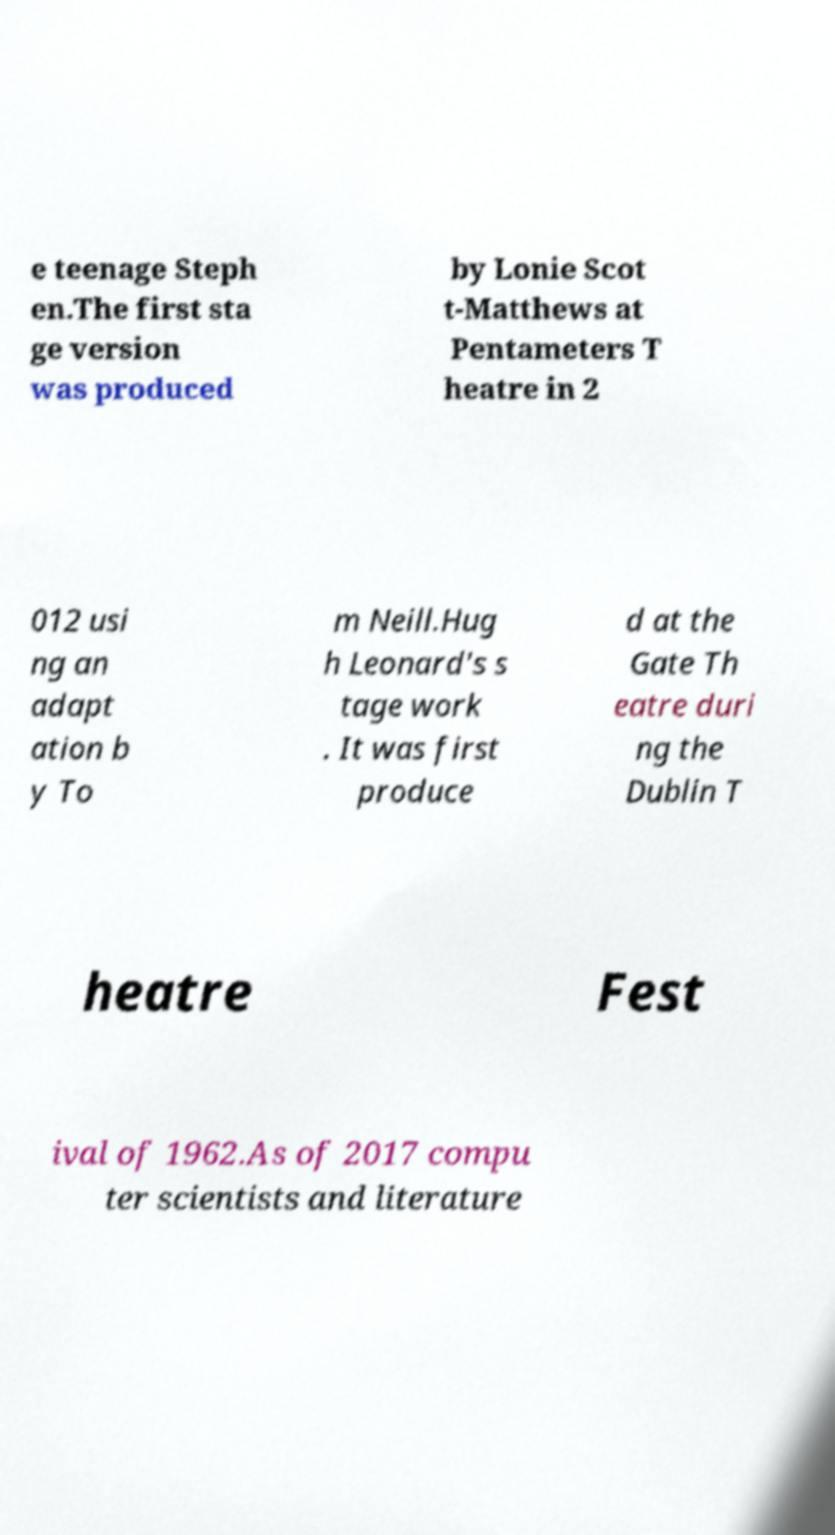There's text embedded in this image that I need extracted. Can you transcribe it verbatim? e teenage Steph en.The first sta ge version was produced by Lonie Scot t-Matthews at Pentameters T heatre in 2 012 usi ng an adapt ation b y To m Neill.Hug h Leonard's s tage work . It was first produce d at the Gate Th eatre duri ng the Dublin T heatre Fest ival of 1962.As of 2017 compu ter scientists and literature 